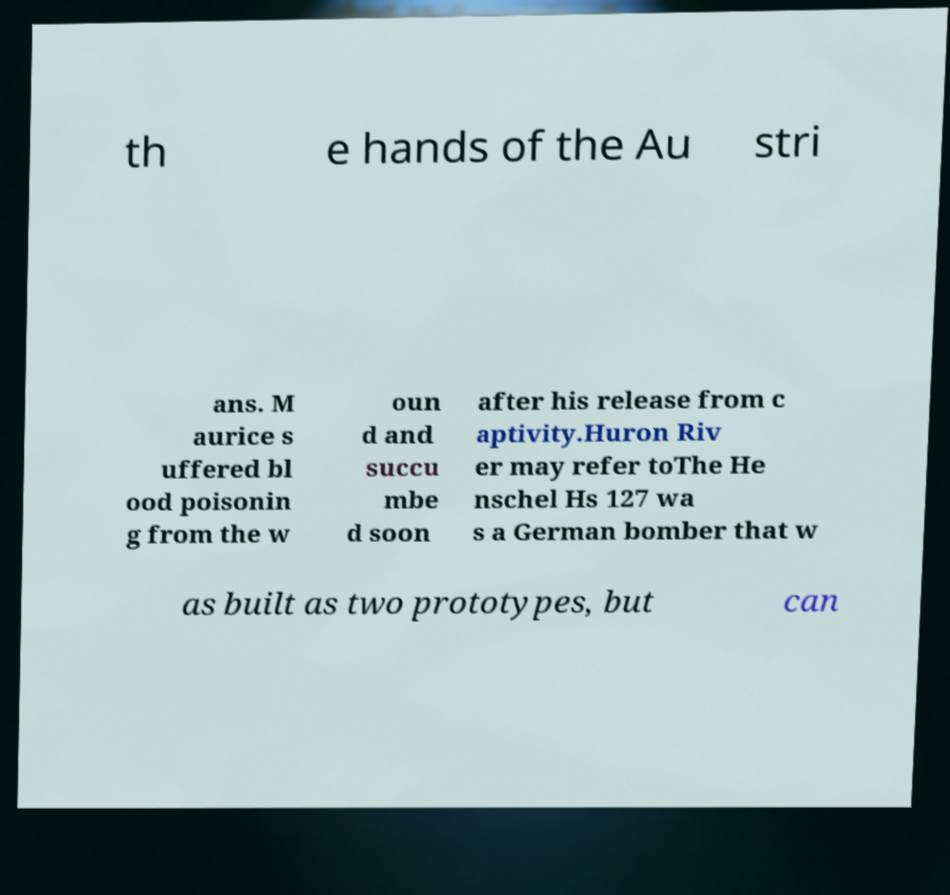What messages or text are displayed in this image? I need them in a readable, typed format. th e hands of the Au stri ans. M aurice s uffered bl ood poisonin g from the w oun d and succu mbe d soon after his release from c aptivity.Huron Riv er may refer toThe He nschel Hs 127 wa s a German bomber that w as built as two prototypes, but can 